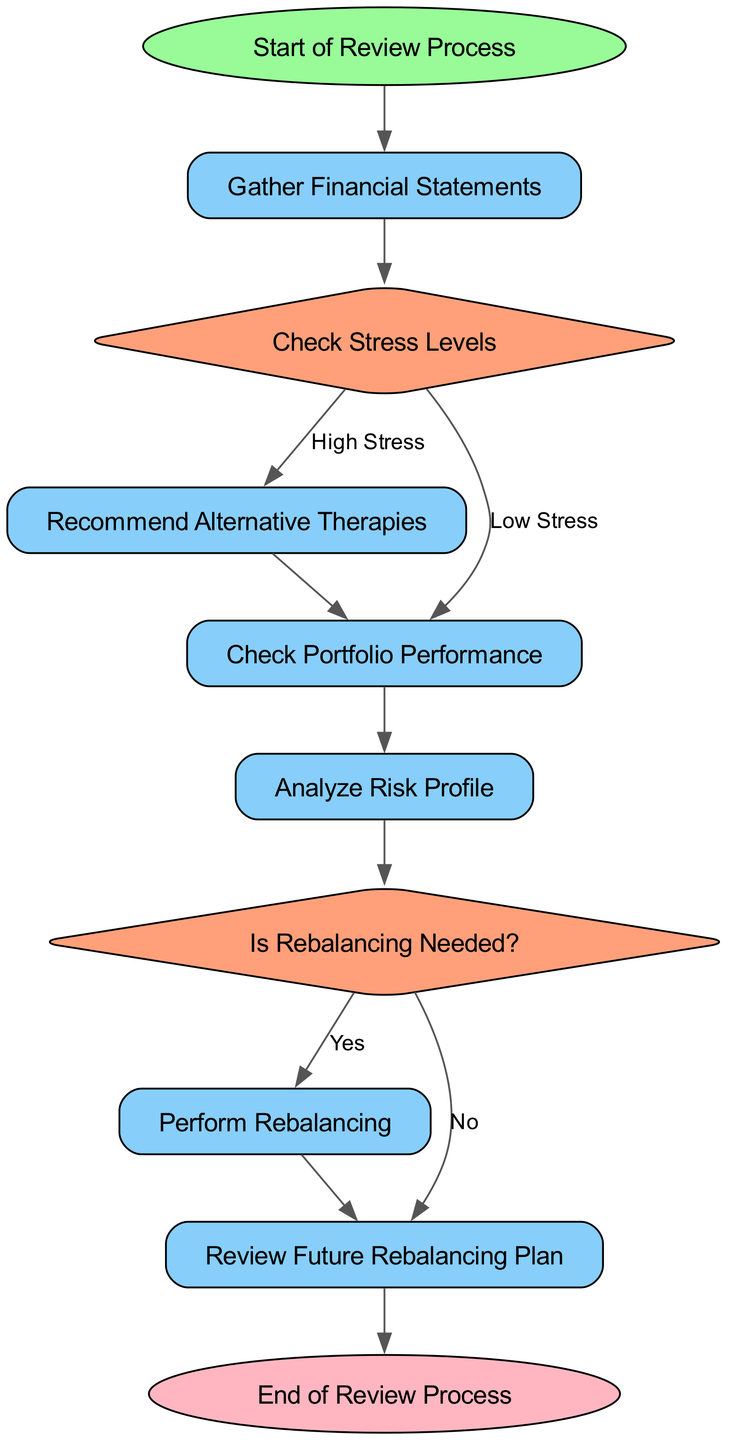What is the first step in the review process? The first step in the review process, as indicated in the diagram, is "Gather Financial Statements," which follows directly from the "Start of Review Process" node.
Answer: Gather Financial Statements How many decision nodes are in the diagram? The diagram contains two decision nodes: "Check Stress Levels" and "Is Rebalancing Needed?" Thus, the count is two decision nodes in total.
Answer: Two If the stress level is low, which node follows next? Following the "Check Stress Levels" node with the option of "Low Stress," the next node is "Check Portfolio Performance." This indicates the flow continuance when facing low stress levels.
Answer: Check Portfolio Performance What action is taken if rebalancing is needed? If the "Is Rebalancing Needed?" decision node indicates "Yes," the next action taken as per the flow is "Perform Rebalancing." This shows the necessary steps responding to that decision.
Answer: Perform Rebalancing What happens after checking portfolio performance regardless of stress levels? After checking portfolio performance, the flow always proceeds to the node "Analyze Risk Profile," indicating this action is consistently followed regardless of prior conditions.
Answer: Analyze Risk Profile In what scenario would the process lead to recommending alternative therapies? The process would lead to "Recommend Alternative Therapies" when the decision from the "Check Stress Levels" node indicates "High Stress," meaning that this action is specifically linked to high-stress levels identified.
Answer: High Stress What is the final node of the review process? The final node of the review process is "End of Review Process," which concludes the entire flow after reviewing the plan. This represents the termination point of the diagram.
Answer: End of Review Process What node comes after performing rebalancing? After "Perform Rebalancing," the next node in the flow is "Review Future Rebalancing Plan," indicating that the review of future plans follows the act of rebalancing.
Answer: Review Future Rebalancing Plan 